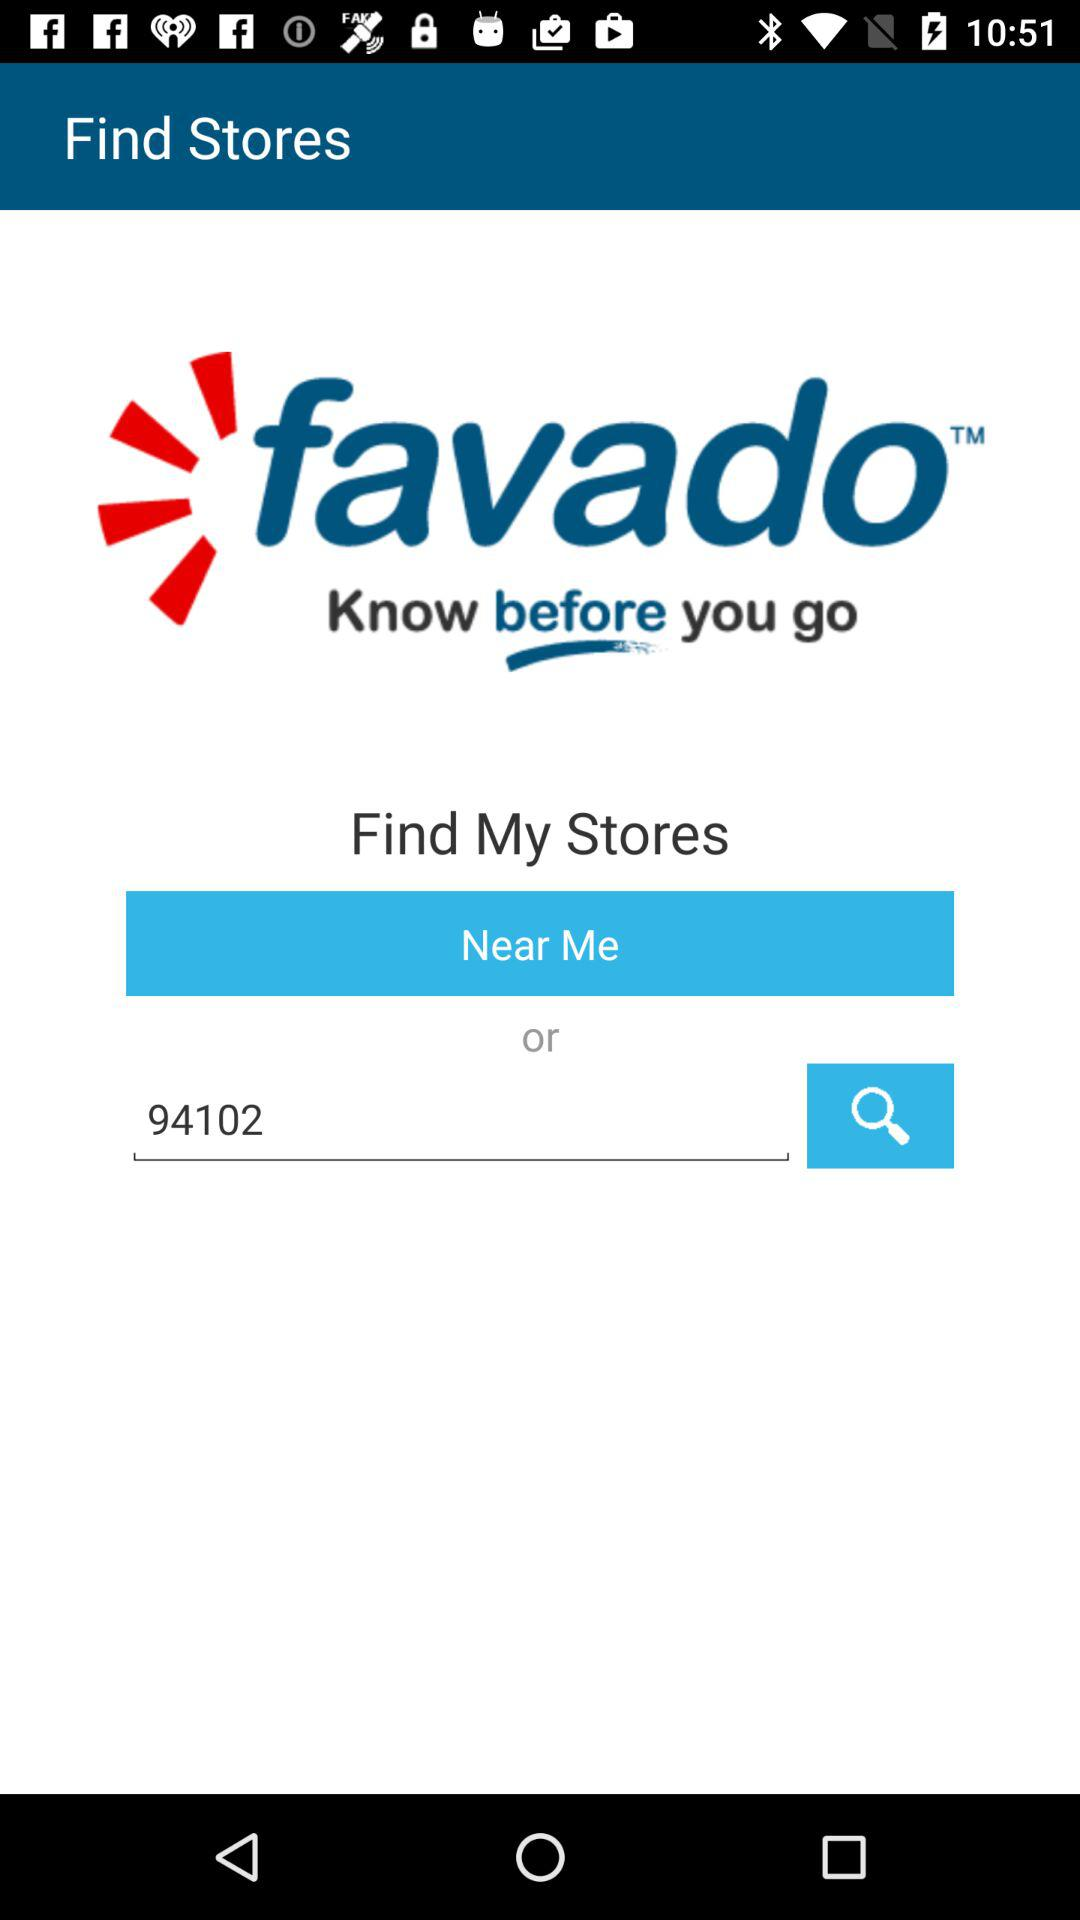What is the code in the search bar? The code in the search bar is 94102. 